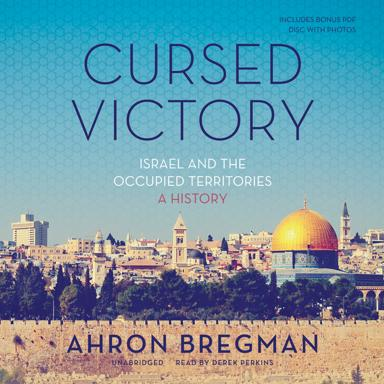What is the title of the book mentioned in the image? The title of the book is "Cursed Victory: Israel and the Occupied Territories: A History" by Ahron Bregman. What format is the book mentioned in the image available in? The book is available in an abridged format and is read by Derek Perkins. What is the bonus item that comes with the book? The bonus item is a pop disc with photos. 